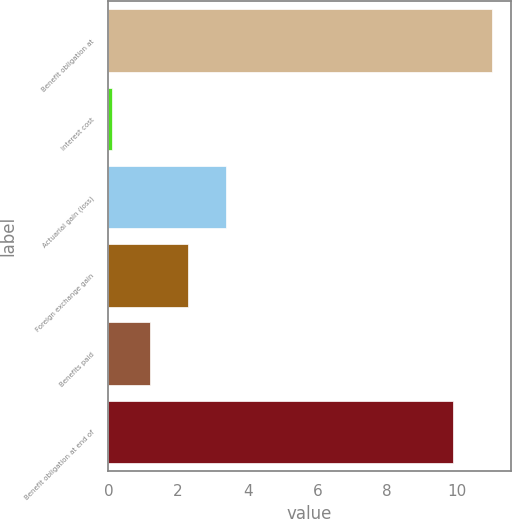Convert chart. <chart><loc_0><loc_0><loc_500><loc_500><bar_chart><fcel>Benefit obligation at<fcel>Interest cost<fcel>Actuarial gain (loss)<fcel>Foreign exchange gain<fcel>Benefits paid<fcel>Benefit obligation at end of<nl><fcel>11<fcel>0.1<fcel>3.37<fcel>2.28<fcel>1.19<fcel>9.9<nl></chart> 